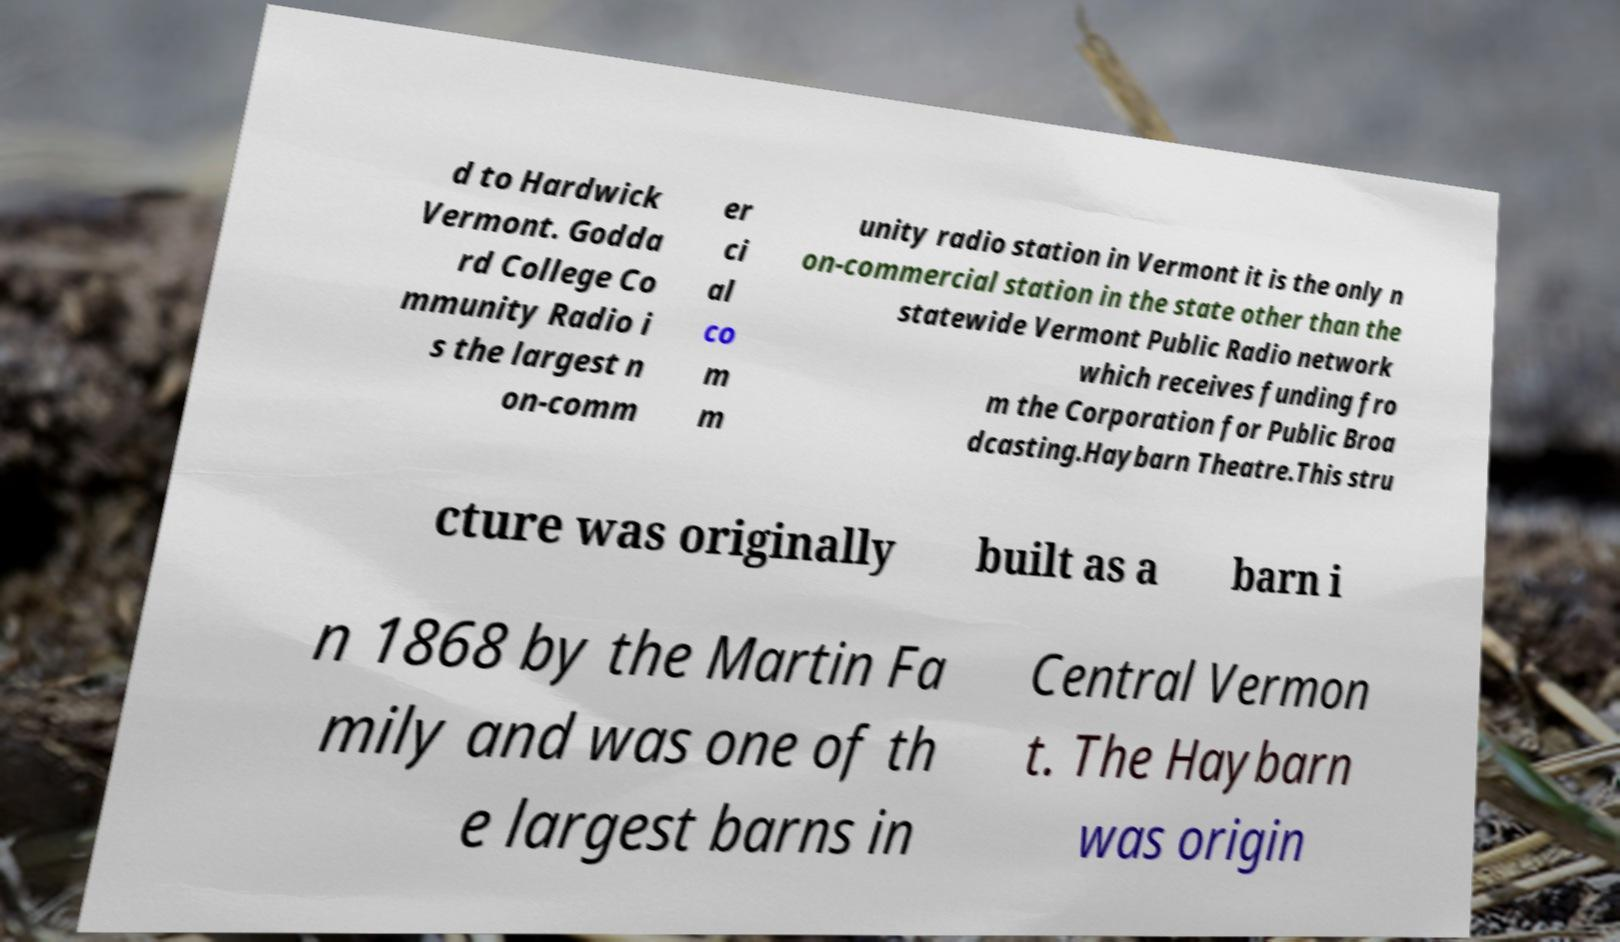Can you read and provide the text displayed in the image?This photo seems to have some interesting text. Can you extract and type it out for me? d to Hardwick Vermont. Godda rd College Co mmunity Radio i s the largest n on-comm er ci al co m m unity radio station in Vermont it is the only n on-commercial station in the state other than the statewide Vermont Public Radio network which receives funding fro m the Corporation for Public Broa dcasting.Haybarn Theatre.This stru cture was originally built as a barn i n 1868 by the Martin Fa mily and was one of th e largest barns in Central Vermon t. The Haybarn was origin 